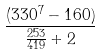<formula> <loc_0><loc_0><loc_500><loc_500>\frac { ( 3 3 0 ^ { 7 } - 1 6 0 ) } { \frac { 2 5 3 } { 4 1 9 } + 2 }</formula> 